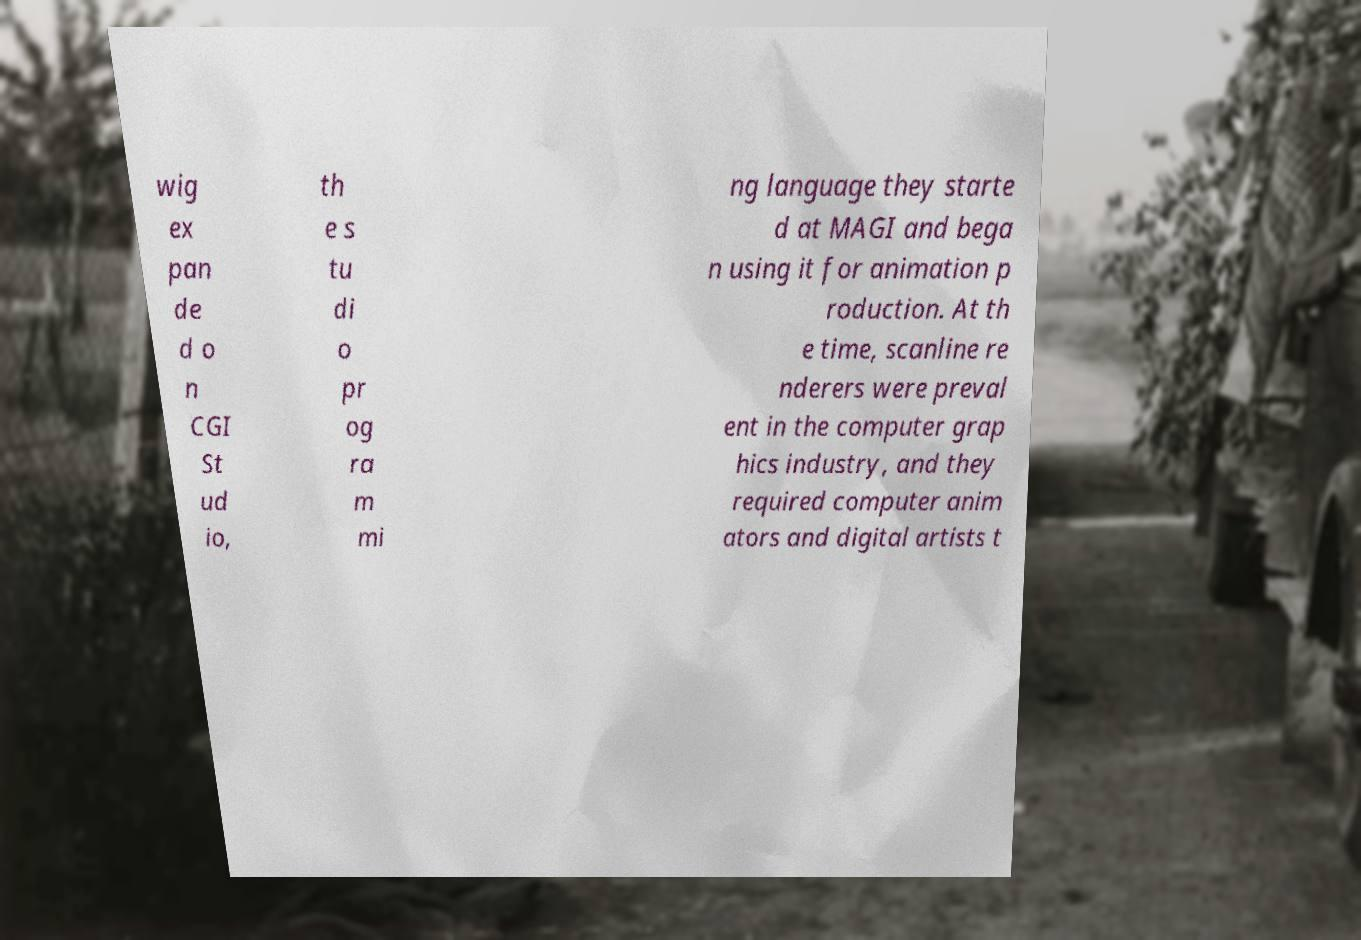Please read and relay the text visible in this image. What does it say? wig ex pan de d o n CGI St ud io, th e s tu di o pr og ra m mi ng language they starte d at MAGI and bega n using it for animation p roduction. At th e time, scanline re nderers were preval ent in the computer grap hics industry, and they required computer anim ators and digital artists t 